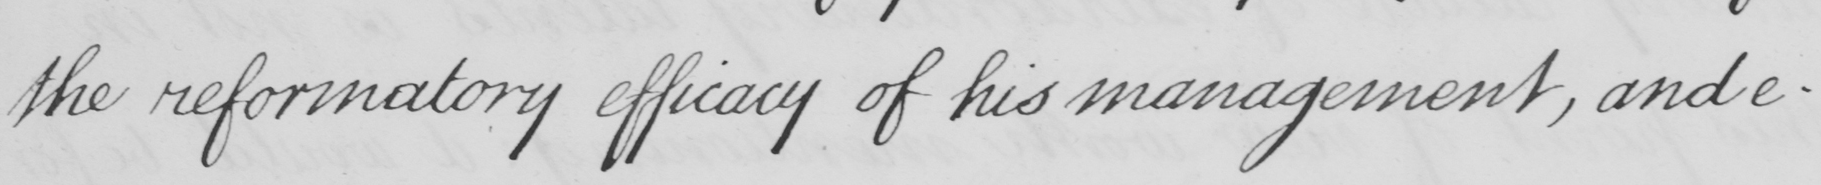Can you tell me what this handwritten text says? the reformatory efficacy of his management , and e- 